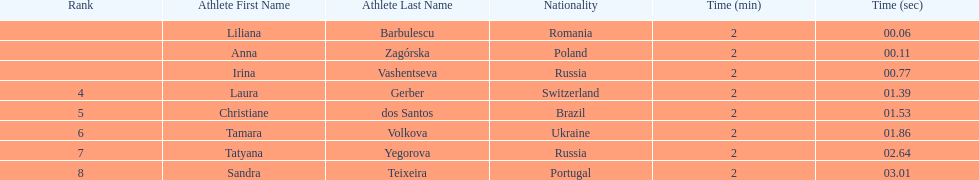Which country had the most finishers in the top 8? Russia. Parse the full table. {'header': ['Rank', 'Athlete First Name', 'Athlete Last Name', 'Nationality', 'Time (min)', 'Time (sec)'], 'rows': [['', 'Liliana', 'Barbulescu', 'Romania', '2', '00.06'], ['', 'Anna', 'Zagórska', 'Poland', '2', '00.11'], ['', 'Irina', 'Vashentseva', 'Russia', '2', '00.77'], ['4', 'Laura', 'Gerber', 'Switzerland', '2', '01.39'], ['5', 'Christiane', 'dos Santos', 'Brazil', '2', '01.53'], ['6', 'Tamara', 'Volkova', 'Ukraine', '2', '01.86'], ['7', 'Tatyana', 'Yegorova', 'Russia', '2', '02.64'], ['8', 'Sandra', 'Teixeira', 'Portugal', '2', '03.01']]} 